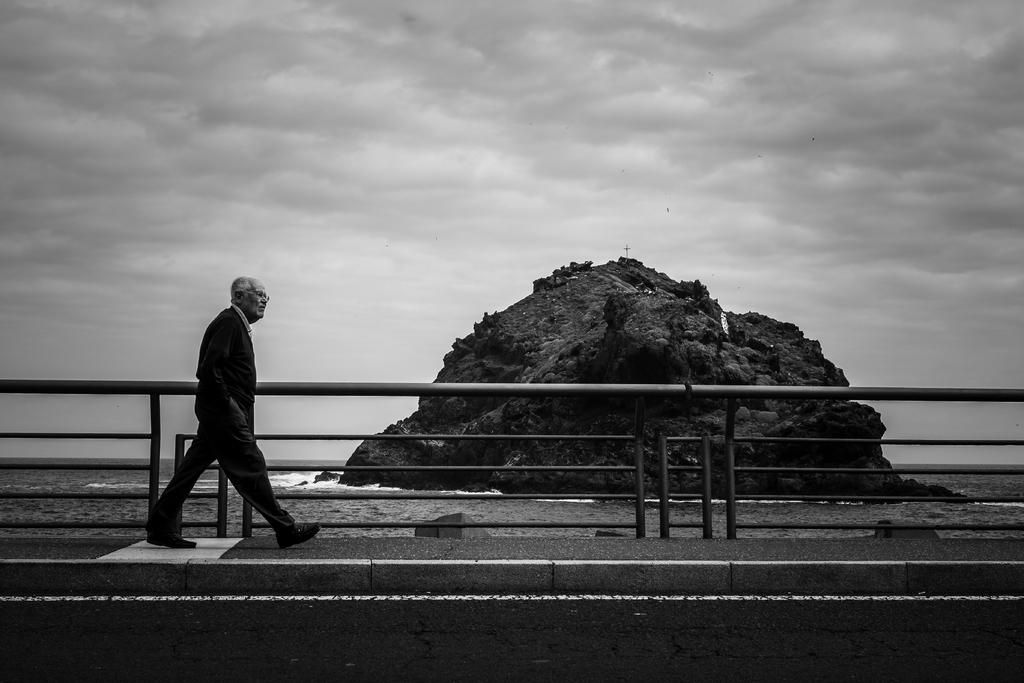What is the person in the image doing? The person is walking in the image. Where is the person walking? The person is on a walkway. What else can be seen in the image besides the person walking? There is a road visible in the image, as well as water, a metal grill fence, and clouds in the sky. What type of cabbage is being grown in the image? There is no cabbage present in the image. Can you describe the locket the person is wearing in the image? There is no locket visible on the person in the image. 